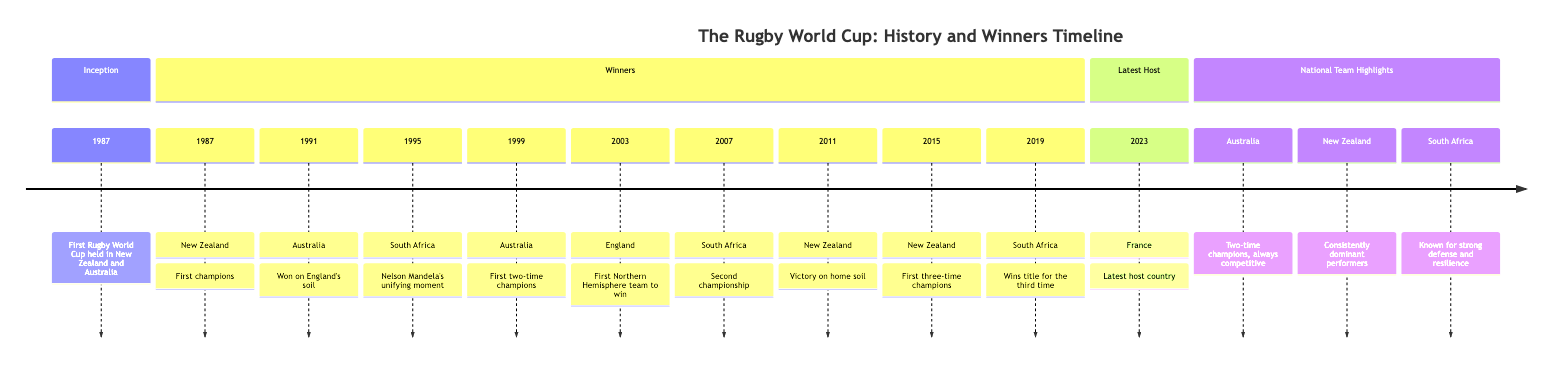What year did the first Rugby World Cup take place? The diagram indicates that the first Rugby World Cup was held in 1987 under the section "Inception." Therefore, the answer is directly drawn from this part of the timeline.
Answer: 1987 Which team won the Rugby World Cup in 1995? In the "Winners" section, the timeline shows that South Africa won the Rugby World Cup in 1995. This is a straightforward retrieval of information from the specified year.
Answer: South Africa How many times has New Zealand won the Rugby World Cup according to the diagram? Looking through the "Winners" section, New Zealand is the winner in 1987, 2011, and 2015. Therefore, by counting these instances, the answer can be deduced.
Answer: Three times What significant event occurred during the 1995 World Cup win by South Africa? The diagram highlights that Nelson Mandela's unifying moment was associated with South Africa's victory in 1995. This context is provided next to the relevant year in the timeline.
Answer: Nelson Mandela's unifying moment Which team is noted for being the "consistently dominant performers"? Under the "National Team Highlights" section, the diagram specifically states that New Zealand is recognized for being consistently dominant. This is a direct citation from that portion of the diagram.
Answer: New Zealand In what year did England become the first Northern Hemisphere team to win the Rugby World Cup? Referring to the "Winners" section, the timeline confirms that England won in 2003. This is directly tied to the specific detail about Northern Hemisphere teams.
Answer: 2003 How many total Rugby World Cup wins does Australia have as depicted? The timeline shows that Australia has won the Rugby World Cup twice, reflecting their victories in 1991 and 1999. The answer can be derived by counting these specific instances.
Answer: Two times What is the latest host country for the Rugby World Cup according to this diagram? The "Latest Host" section clearly outlines that France is the host country for the Rugby World Cup in 2023, making this an easy data point to access.
Answer: France Based on the diagram, how many times did South Africa win the Rugby World Cup? From the "Winners" section, we see that South Africa won in 1995, 2007, and 2019, which totals three wins. This requires addition of the victories listed there.
Answer: Three times 